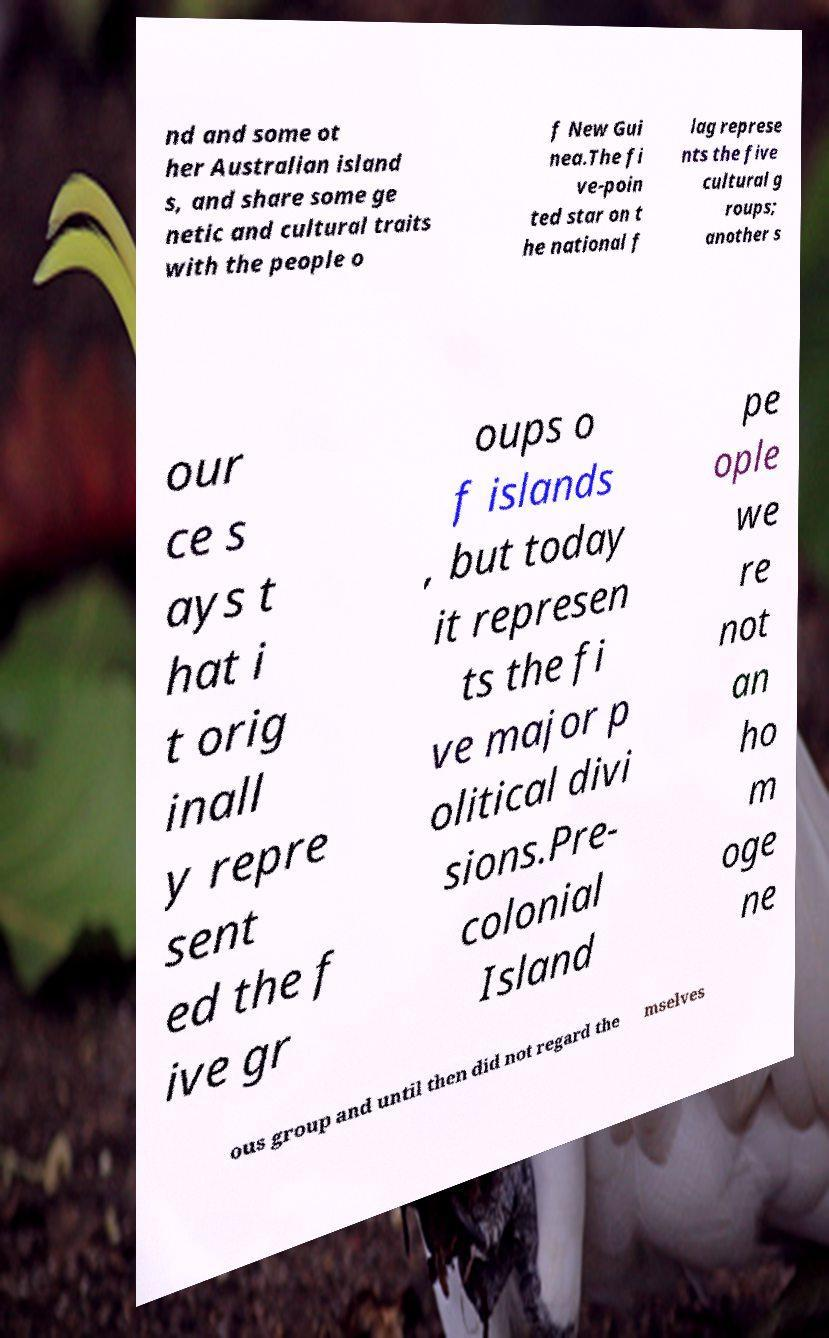What messages or text are displayed in this image? I need them in a readable, typed format. nd and some ot her Australian island s, and share some ge netic and cultural traits with the people o f New Gui nea.The fi ve-poin ted star on t he national f lag represe nts the five cultural g roups; another s our ce s ays t hat i t orig inall y repre sent ed the f ive gr oups o f islands , but today it represen ts the fi ve major p olitical divi sions.Pre- colonial Island pe ople we re not an ho m oge ne ous group and until then did not regard the mselves 